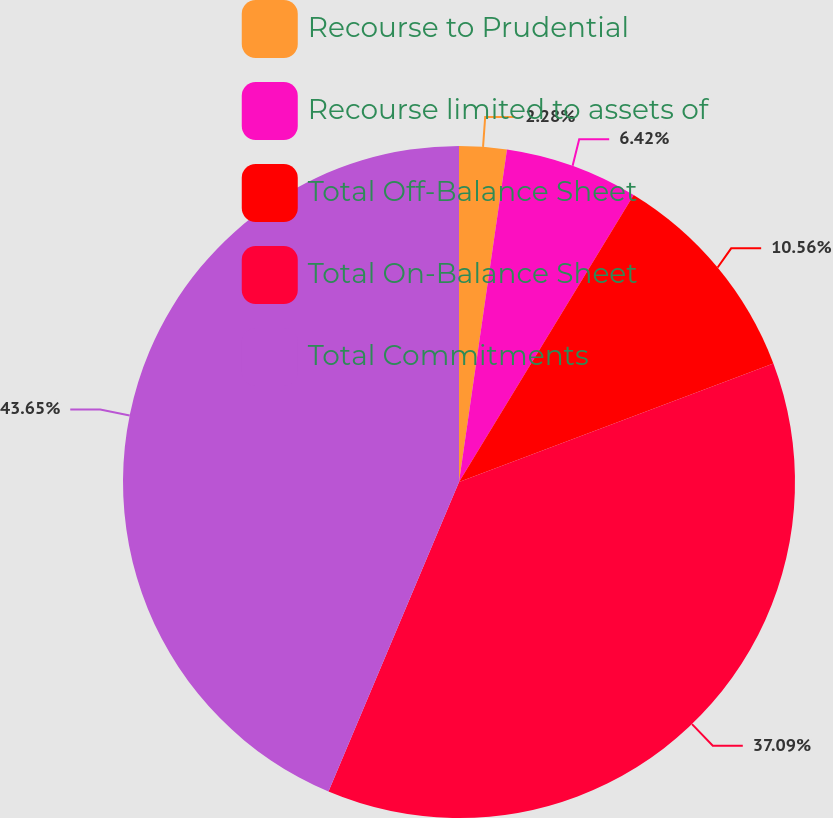Convert chart to OTSL. <chart><loc_0><loc_0><loc_500><loc_500><pie_chart><fcel>Recourse to Prudential<fcel>Recourse limited to assets of<fcel>Total Off-Balance Sheet<fcel>Total On-Balance Sheet<fcel>Total Commitments<nl><fcel>2.28%<fcel>6.42%<fcel>10.56%<fcel>37.09%<fcel>43.65%<nl></chart> 